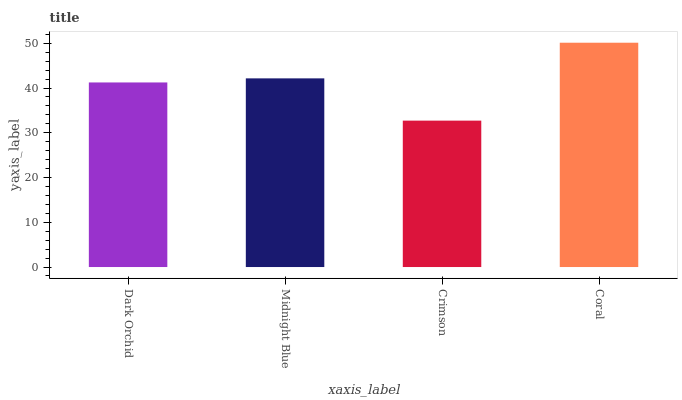Is Crimson the minimum?
Answer yes or no. Yes. Is Coral the maximum?
Answer yes or no. Yes. Is Midnight Blue the minimum?
Answer yes or no. No. Is Midnight Blue the maximum?
Answer yes or no. No. Is Midnight Blue greater than Dark Orchid?
Answer yes or no. Yes. Is Dark Orchid less than Midnight Blue?
Answer yes or no. Yes. Is Dark Orchid greater than Midnight Blue?
Answer yes or no. No. Is Midnight Blue less than Dark Orchid?
Answer yes or no. No. Is Midnight Blue the high median?
Answer yes or no. Yes. Is Dark Orchid the low median?
Answer yes or no. Yes. Is Dark Orchid the high median?
Answer yes or no. No. Is Coral the low median?
Answer yes or no. No. 